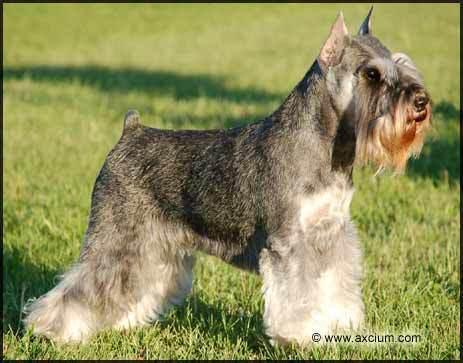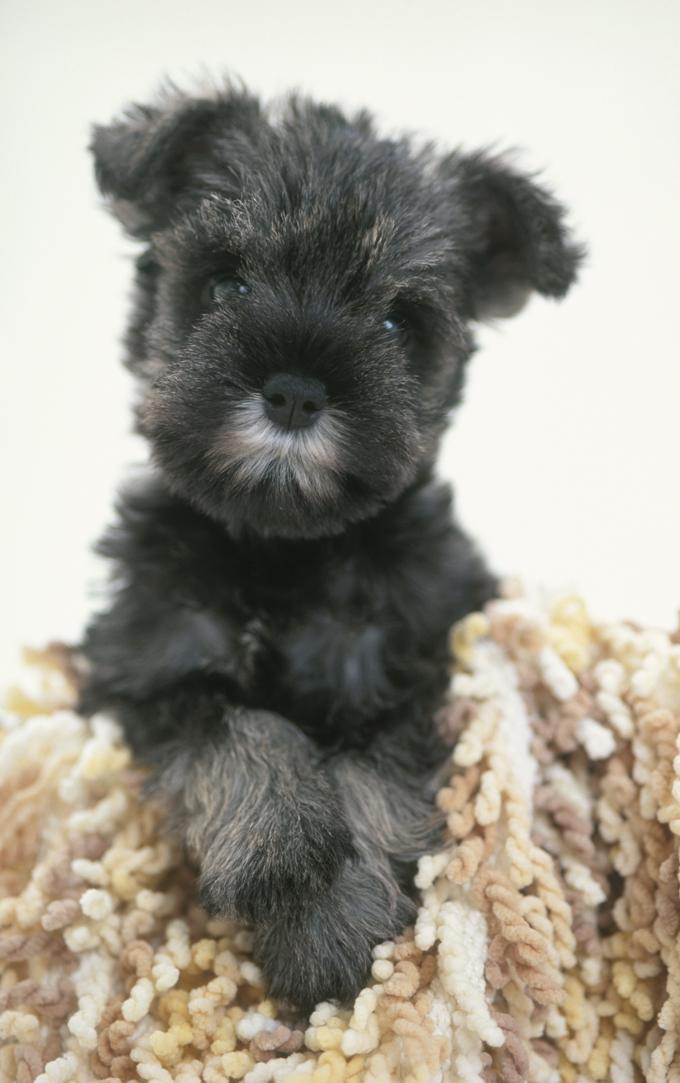The first image is the image on the left, the second image is the image on the right. Evaluate the accuracy of this statement regarding the images: "At least one of the dogs is not outside.". Is it true? Answer yes or no. Yes. The first image is the image on the left, the second image is the image on the right. Analyze the images presented: Is the assertion "The dog in the right image is sitting on grass looking towards the right." valid? Answer yes or no. No. The first image is the image on the left, the second image is the image on the right. For the images displayed, is the sentence "At least one dog has no visible collar on." factually correct? Answer yes or no. Yes. 